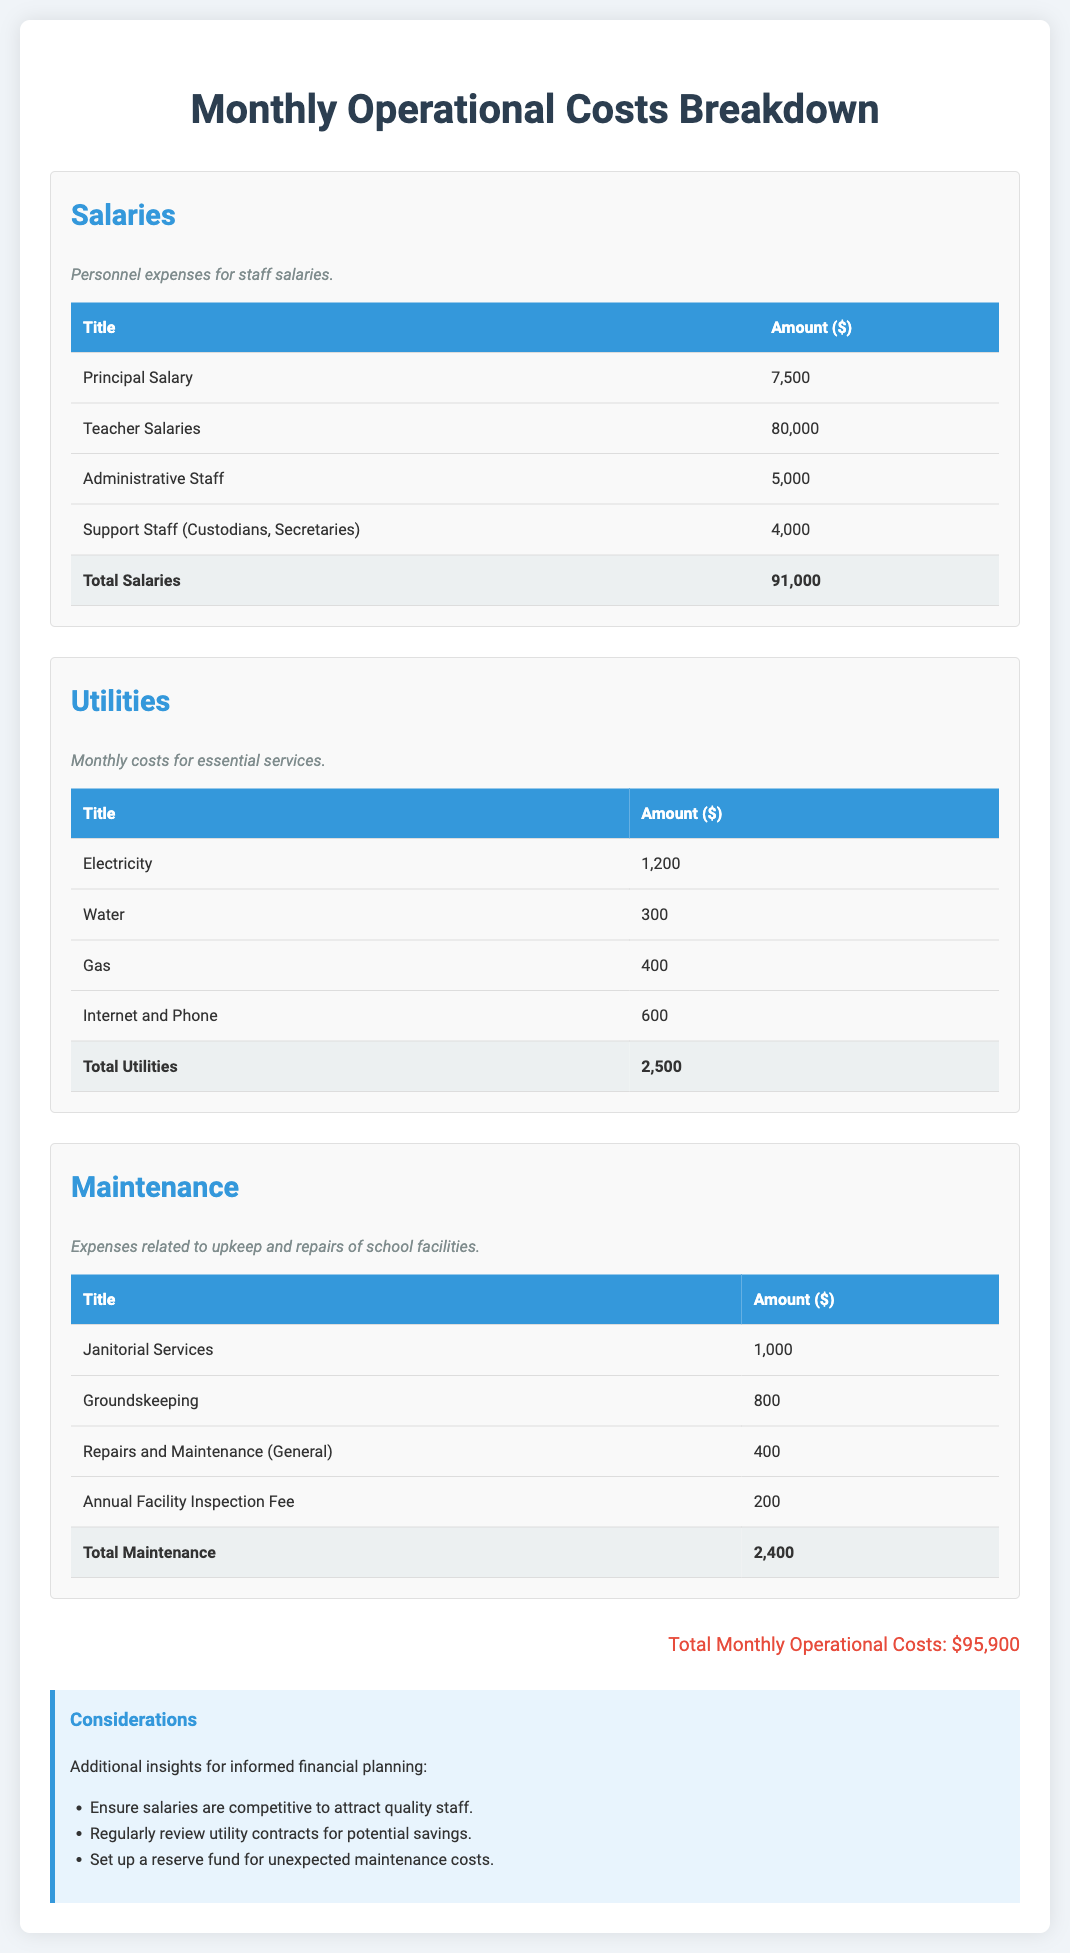What is the total amount spent on salaries? The total amount spent on salaries is found in the Salaries section, which sums up to $91,000.
Answer: $91,000 How much is allocated for utilities? The total amount allocated for utilities is listed in the Utilities section as $2,500.
Answer: $2,500 What is the monthly cost for janitorial services? The monthly cost for janitorial services is specifically mentioned in the Maintenance section as $1,000.
Answer: $1,000 What is the total monthly operational cost for the school? The total monthly operational cost is calculated as the sum of salaries, utilities, and maintenance costs, which equals $95,900.
Answer: $95,900 Which utility has the highest monthly cost? The utility with the highest monthly cost is electricity, which amounts to $1,200.
Answer: Electricity What is the sum of all maintenance costs? The total for maintenance costs can be calculated from individual items in the Maintenance section, resulting in $2,400.
Answer: $2,400 What percentage of the total operational costs does utilities represent? Utilities amount to $2,500, which is approximately 2.61% of the total operational costs of $95,900.
Answer: 2.61% What can be done to attract quality staff according to the considerations? According to the considerations, ensuring competitive salaries can attract quality staff.
Answer: Competitive salaries What expense is categorized under Support Staff? The expense categorized under Support Staff is for custodians and secretaries, which is $4,000.
Answer: Custodians, Secretaries How much is allocated for repairs and maintenance? The allocated amount specifically for repairs and maintenance in the Maintenance section is $400.
Answer: $400 